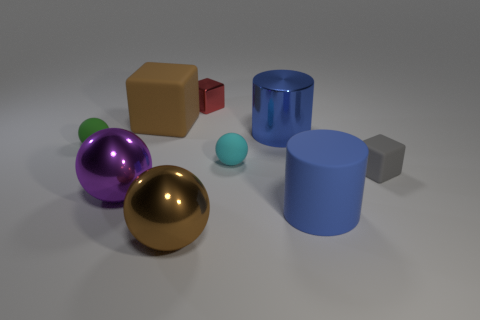Add 1 gray matte things. How many objects exist? 10 Subtract all spheres. How many objects are left? 5 Add 3 big gray cylinders. How many big gray cylinders exist? 3 Subtract 0 yellow blocks. How many objects are left? 9 Subtract all tiny purple rubber cubes. Subtract all big rubber cubes. How many objects are left? 8 Add 6 big metallic balls. How many big metallic balls are left? 8 